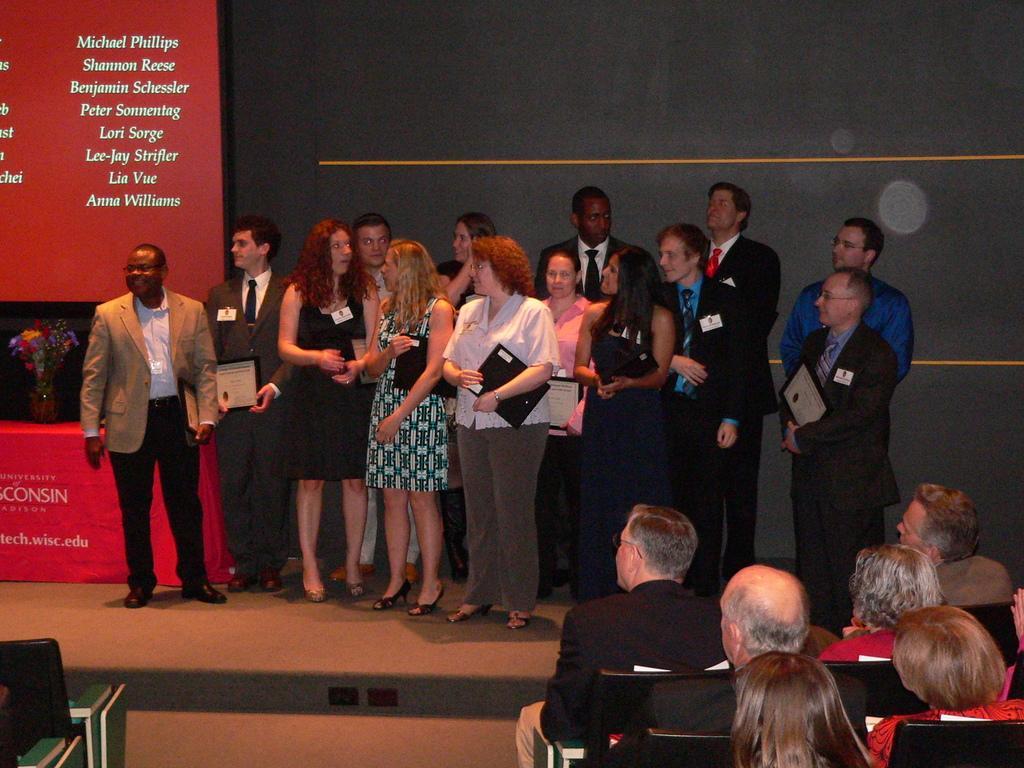How would you summarize this image in a sentence or two? In this image we can see one red tablecloth with text on the table, one flower pot with flowers on the table, one red board with text on the left side of the image, some chairs in front of the stage, some people are sitting on the chairs, some people are holding objects, some people are standing, there is a wall in the background, two objects attached to the stage in the middle of the image and some white objects near the chairs on the right side of the image. 